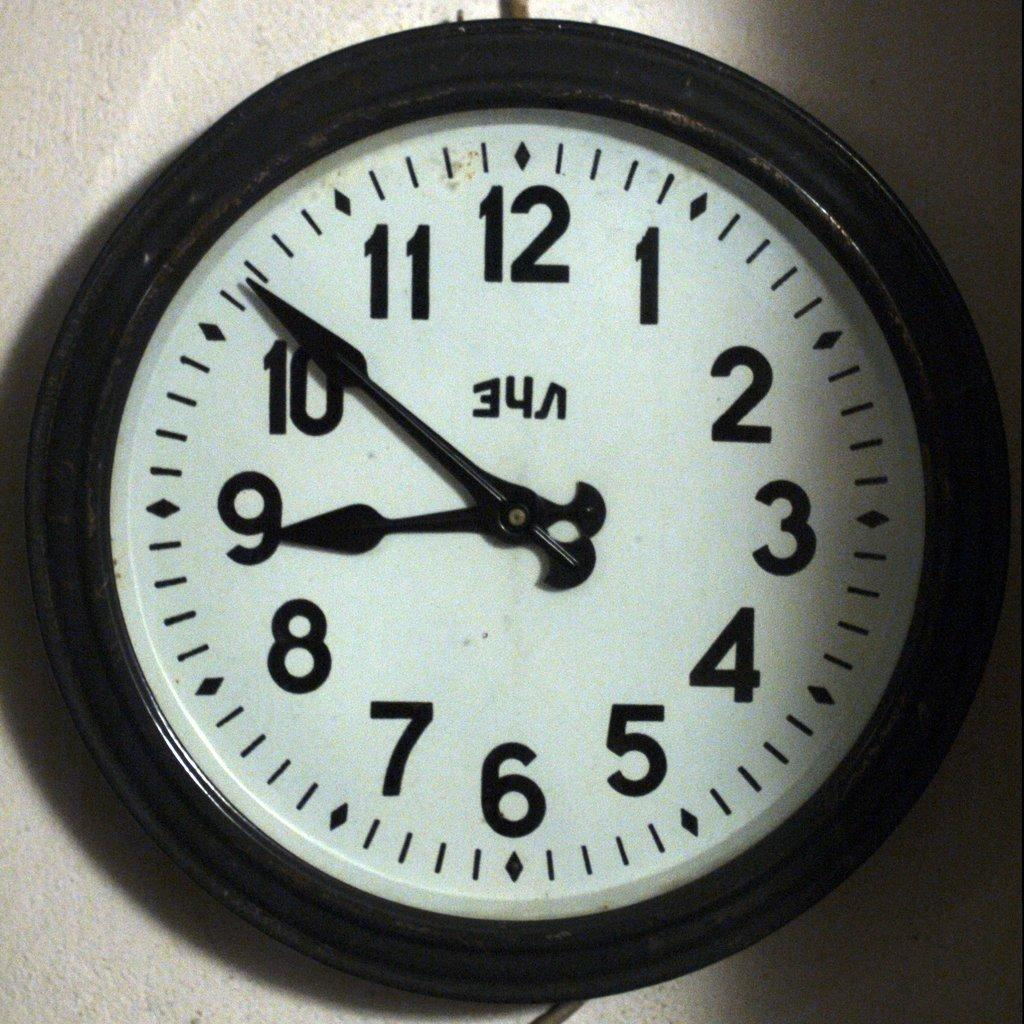<image>
Relay a brief, clear account of the picture shown. A black and white wall clock that shows a time of 8:51. 